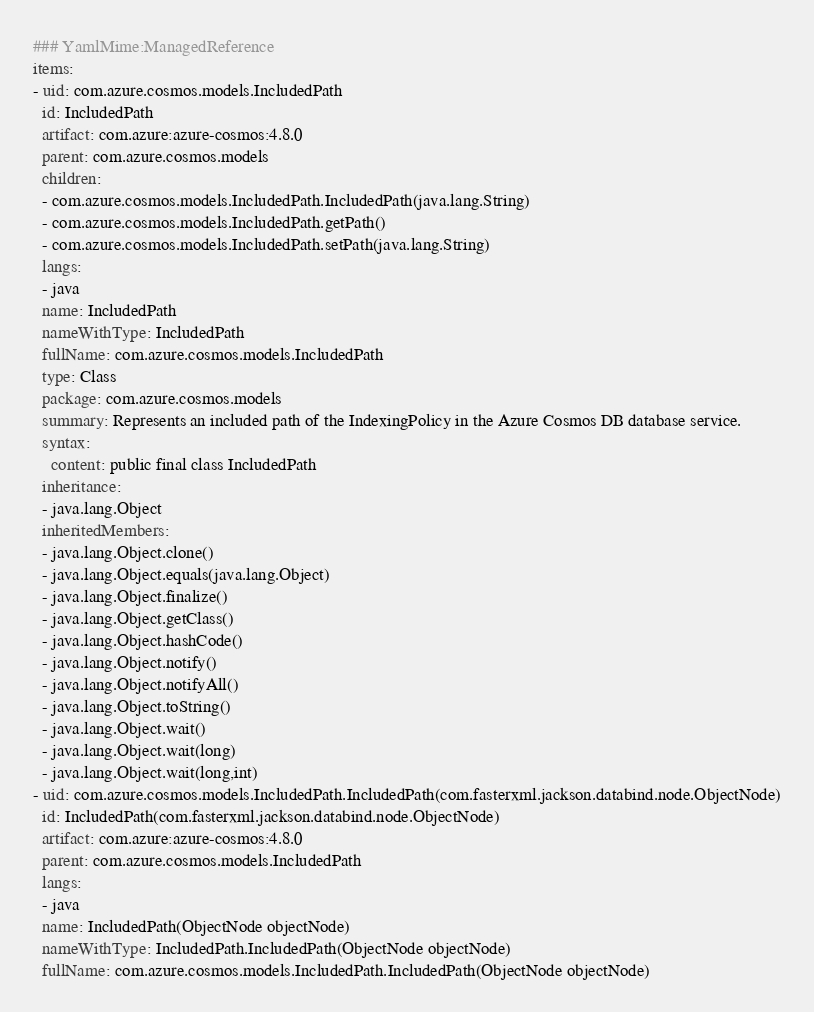Convert code to text. <code><loc_0><loc_0><loc_500><loc_500><_YAML_>### YamlMime:ManagedReference
items:
- uid: com.azure.cosmos.models.IncludedPath
  id: IncludedPath
  artifact: com.azure:azure-cosmos:4.8.0
  parent: com.azure.cosmos.models
  children:
  - com.azure.cosmos.models.IncludedPath.IncludedPath(java.lang.String)
  - com.azure.cosmos.models.IncludedPath.getPath()
  - com.azure.cosmos.models.IncludedPath.setPath(java.lang.String)
  langs:
  - java
  name: IncludedPath
  nameWithType: IncludedPath
  fullName: com.azure.cosmos.models.IncludedPath
  type: Class
  package: com.azure.cosmos.models
  summary: Represents an included path of the IndexingPolicy in the Azure Cosmos DB database service.
  syntax:
    content: public final class IncludedPath
  inheritance:
  - java.lang.Object
  inheritedMembers:
  - java.lang.Object.clone()
  - java.lang.Object.equals(java.lang.Object)
  - java.lang.Object.finalize()
  - java.lang.Object.getClass()
  - java.lang.Object.hashCode()
  - java.lang.Object.notify()
  - java.lang.Object.notifyAll()
  - java.lang.Object.toString()
  - java.lang.Object.wait()
  - java.lang.Object.wait(long)
  - java.lang.Object.wait(long,int)
- uid: com.azure.cosmos.models.IncludedPath.IncludedPath(com.fasterxml.jackson.databind.node.ObjectNode)
  id: IncludedPath(com.fasterxml.jackson.databind.node.ObjectNode)
  artifact: com.azure:azure-cosmos:4.8.0
  parent: com.azure.cosmos.models.IncludedPath
  langs:
  - java
  name: IncludedPath(ObjectNode objectNode)
  nameWithType: IncludedPath.IncludedPath(ObjectNode objectNode)
  fullName: com.azure.cosmos.models.IncludedPath.IncludedPath(ObjectNode objectNode)</code> 